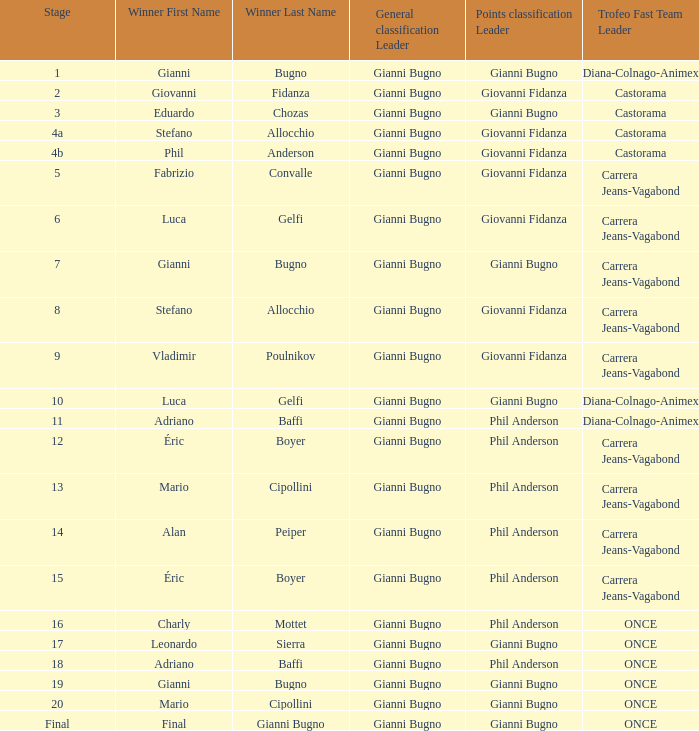In stage 5 of the trofeo fast team, who claims victory when carrera jeans-vagabond competes? Fabrizio Convalle. 